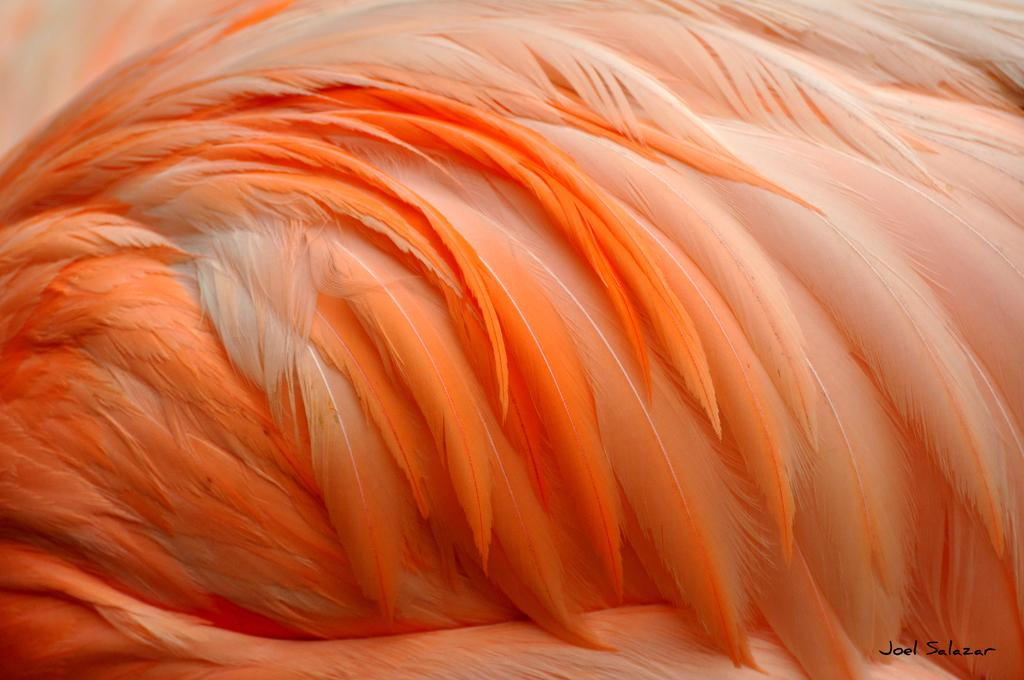What type of objects can be seen in the image? There are feathers in the image. Can you describe the appearance of the feathers? The feathers are orange in color. What type of parcel is wrapped with the orange feathers in the image? There is no parcel present in the image; it only features orange feathers. 